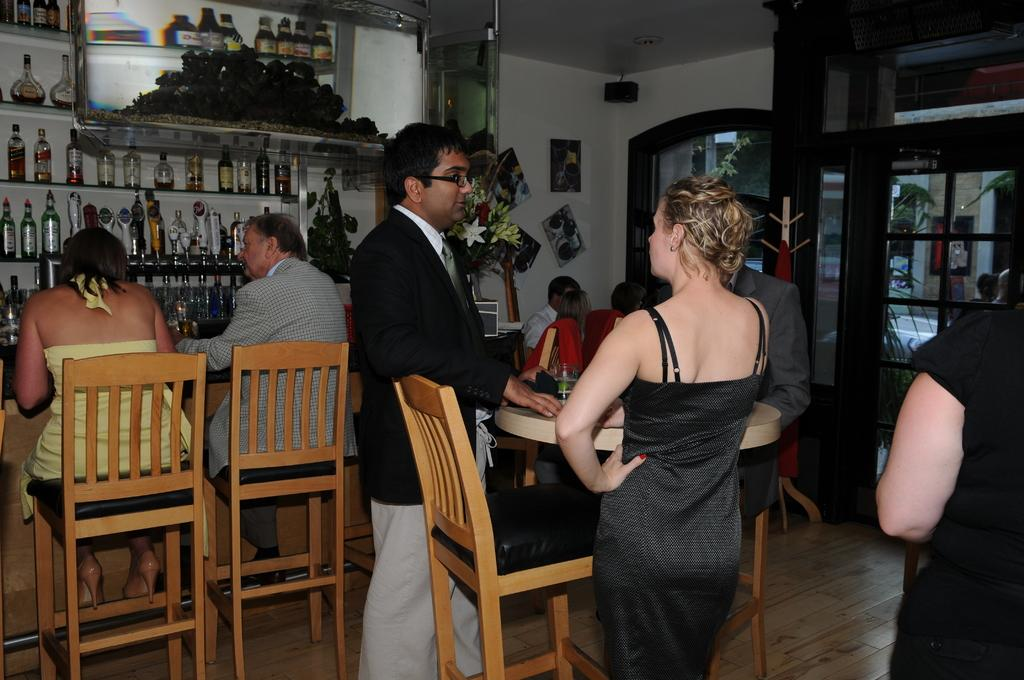How many people are standing in front of the table in the image? There are two persons standing in front of the table in the image. What are the other people in the image doing? There is a group of members sitting beside the standing persons. Where are the wine bottles located in the image? The wine bottles are in the left corner of the image. What type of alarm can be heard going off in the image? There is no alarm present in the image, and therefore no sound can be heard. 